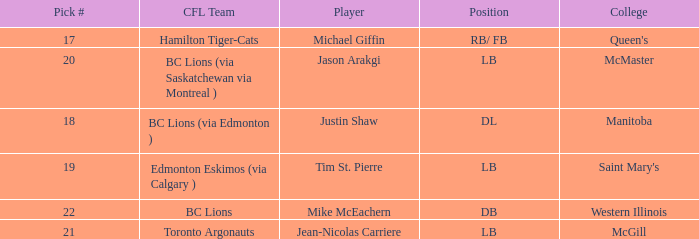How many cfl teams had pick # 21? 1.0. 